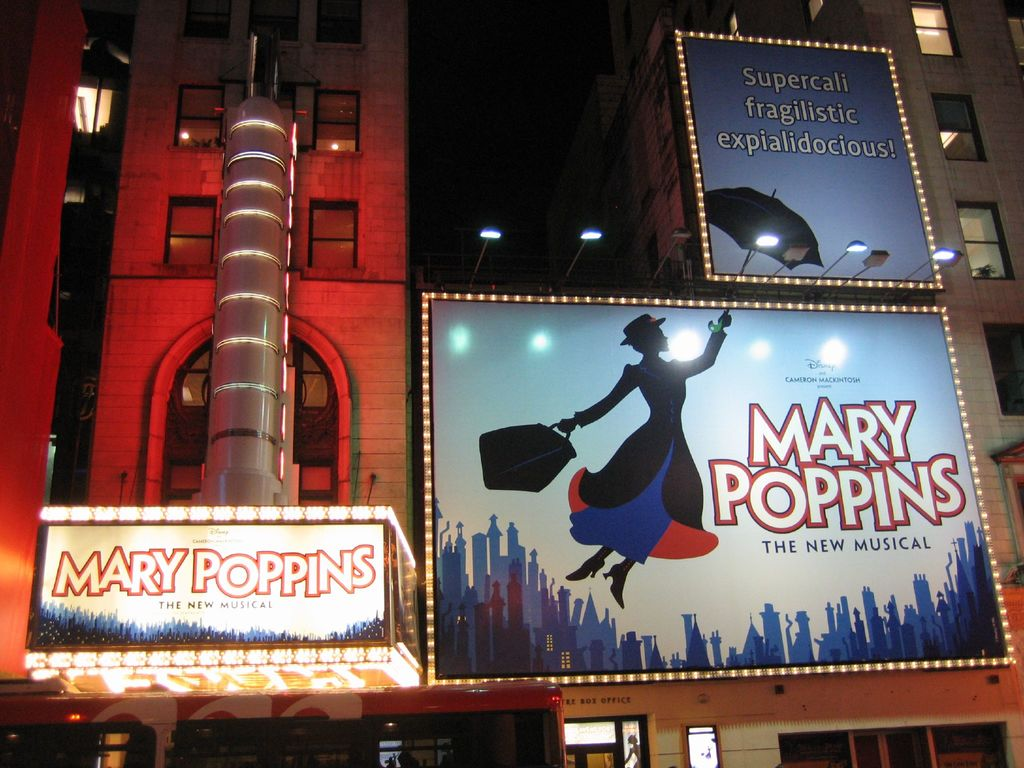What is this photo about? The photograph captures a lively night scene outside a theater celebrating the production of 'Mary Poppins The New Musical'. The theater's facade glows under the lights of a brightly lit marquee that titles the show, surrounded by vibrant billboards featuring Mary Poppins floating above a stylized cityscape. Above the scene, the playfully long word 'Supercalifragilisticexpialidocious!' is highlighted, adding a magical and whimsical flair that evokes the spirit of the musical. This engaging setting not only advertises the show but also entices passersby and theatergoers with a promise of a delightful and enchanting experience. 